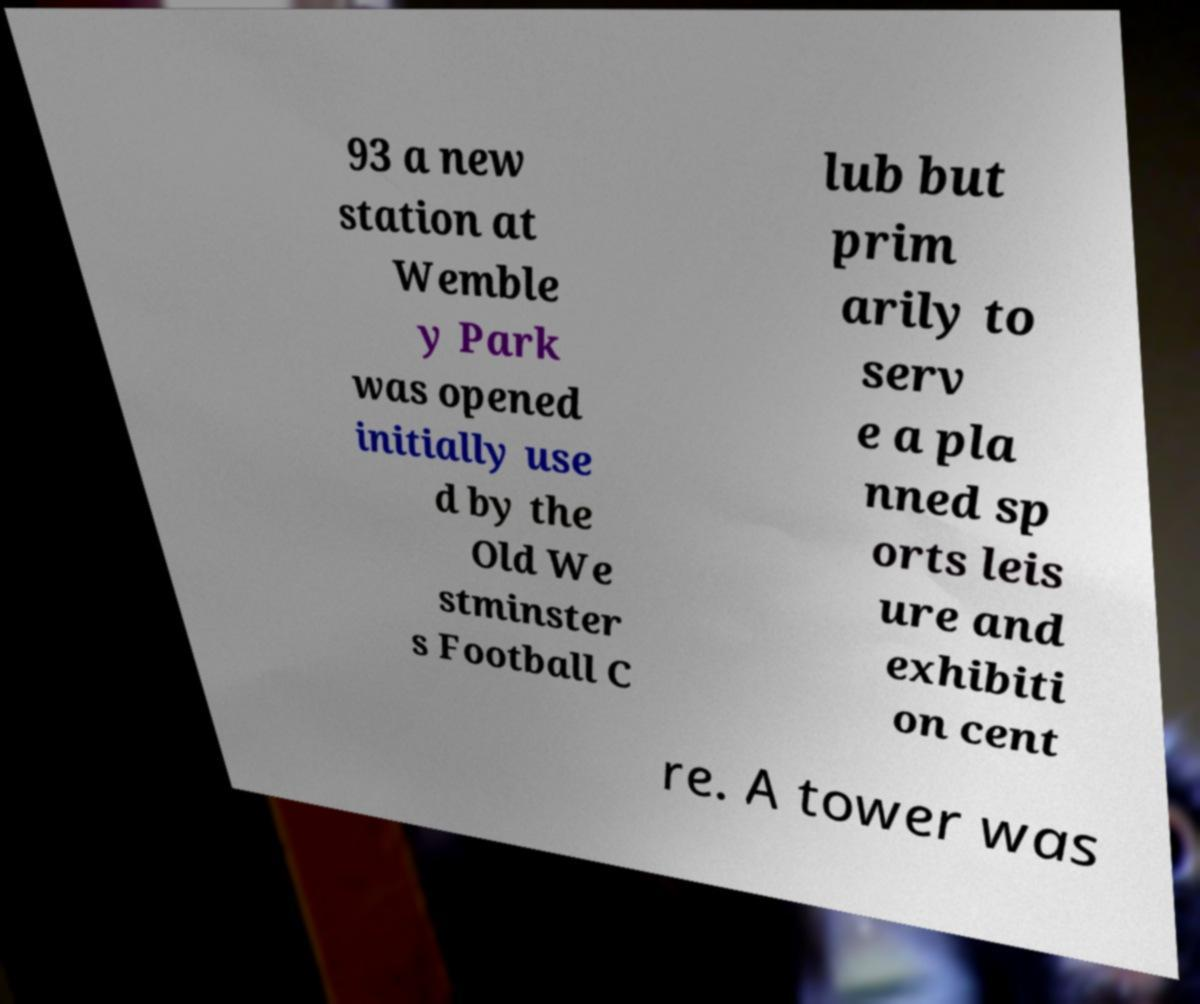Can you accurately transcribe the text from the provided image for me? 93 a new station at Wemble y Park was opened initially use d by the Old We stminster s Football C lub but prim arily to serv e a pla nned sp orts leis ure and exhibiti on cent re. A tower was 